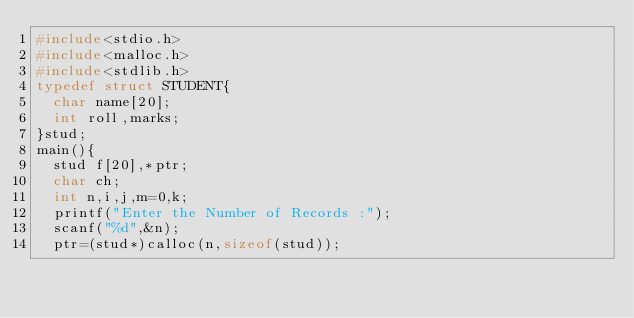<code> <loc_0><loc_0><loc_500><loc_500><_C++_>#include<stdio.h>
#include<malloc.h>
#include<stdlib.h>
typedef struct STUDENT{
	char name[20];
	int roll,marks;
}stud;
main(){
	stud f[20],*ptr;
	char ch;
	int n,i,j,m=0,k;
	printf("Enter the Number of Records :");
	scanf("%d",&n);
	ptr=(stud*)calloc(n,sizeof(stud));</code> 